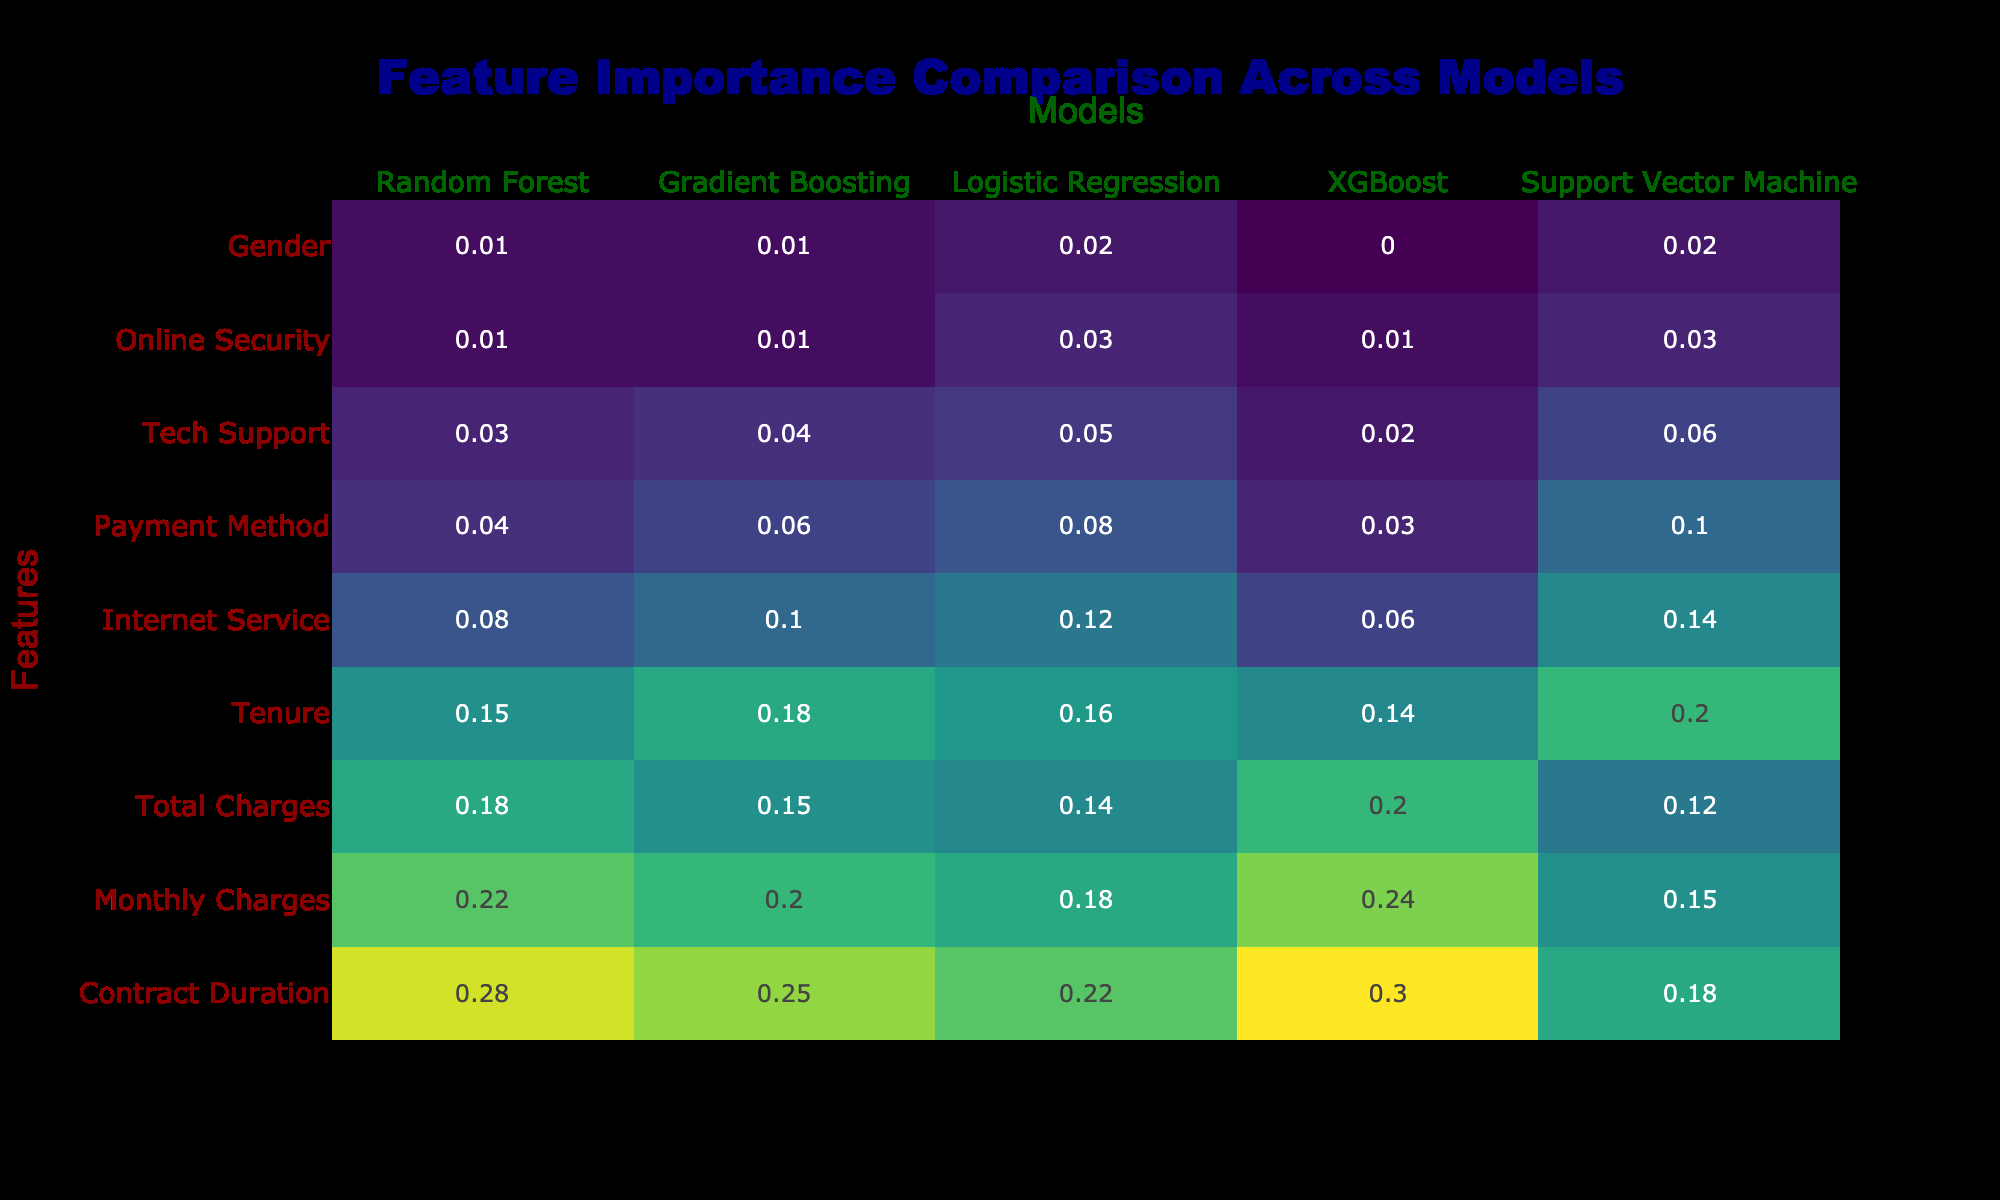What is the feature importance score for Contract Duration in the XGBoost model? The table shows the feature importance score for Contract Duration under the XGBoost model as 0.30.
Answer: 0.30 Which model has the highest feature importance score for Monthly Charges? In the table, the feature importance score for Monthly Charges is highest in the Random Forest model with a score of 0.22.
Answer: Random Forest What is the difference in feature importance scores for Total Charges between the Random Forest and Support Vector Machine models? The scores are 0.18 for Random Forest and 0.12 for Support Vector Machine. The difference is 0.18 - 0.12 = 0.06.
Answer: 0.06 Is the feature importance score for Payment Method higher than that of Internet Service in Logistic Regression? The feature importance score for Payment Method is 0.08, and for Internet Service, it is 0.12. Since 0.08 is less than 0.12, the statement is false.
Answer: No Which model has the lowest feature importance score for Tech Support, and what is that score? The table shows that the XGBoost model has the lowest feature importance score for Tech Support, which is 0.02.
Answer: XGBoost, 0.02 What is the average feature importance score of Tenure across all models? The scores for Tenure are 0.15 (Random Forest), 0.18 (Gradient Boosting), 0.16 (Logistic Regression), 0.14 (XGBoost), and 0.20 (Support Vector Machine). The average score is (0.15 + 0.18 + 0.16 + 0.14 + 0.20) / 5 = 0.166.
Answer: 0.166 Which feature has the highest overall importance score across all models? By looking at the highest scores for each feature across all models, Contract Duration has the highest overall score at 0.30.
Answer: Contract Duration Is there a feature that has exactly the same importance score in both Random Forest and Gradient Boosting models? The question asks for the features with equal importance in both models. Checking the table, the feature importance for Online Security in Random Forest (0.01) matches that in Gradient Boosting (0.01). Therefore, the statement is true.
Answer: Yes 